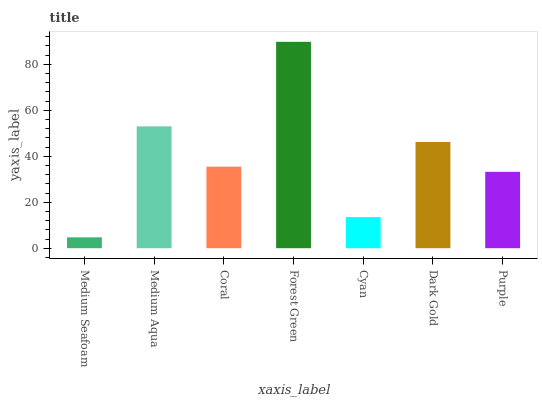Is Medium Seafoam the minimum?
Answer yes or no. Yes. Is Forest Green the maximum?
Answer yes or no. Yes. Is Medium Aqua the minimum?
Answer yes or no. No. Is Medium Aqua the maximum?
Answer yes or no. No. Is Medium Aqua greater than Medium Seafoam?
Answer yes or no. Yes. Is Medium Seafoam less than Medium Aqua?
Answer yes or no. Yes. Is Medium Seafoam greater than Medium Aqua?
Answer yes or no. No. Is Medium Aqua less than Medium Seafoam?
Answer yes or no. No. Is Coral the high median?
Answer yes or no. Yes. Is Coral the low median?
Answer yes or no. Yes. Is Medium Aqua the high median?
Answer yes or no. No. Is Medium Seafoam the low median?
Answer yes or no. No. 